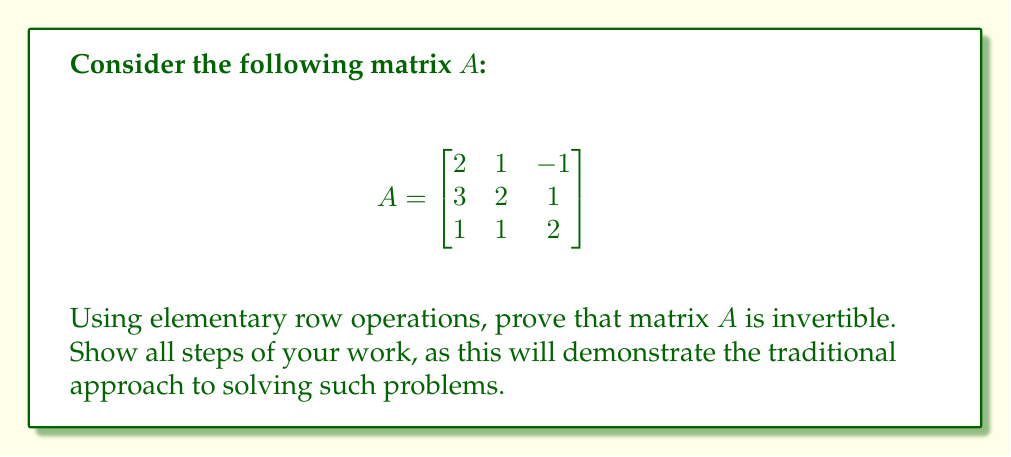Solve this math problem. To prove that matrix $A$ is invertible using elementary row operations, we need to show that we can reduce it to the identity matrix. This process is equivalent to finding the reduced row echelon form (RREF) of the matrix. If we can obtain the identity matrix through elementary row operations, then the matrix is invertible.

Let's proceed step by step:

1) First, we'll augment matrix $A$ with the identity matrix:

   $$\begin{bmatrix}
   2 & 1 & -1 & | & 1 & 0 & 0 \\
   3 & 2 & 1 & | & 0 & 1 & 0 \\
   1 & 1 & 2 & | & 0 & 0 & 1
   \end{bmatrix}$$

2) Now, we'll perform elementary row operations:

   a) Multiply the first row by $-\frac{3}{2}$ and add it to the second row:
   
   $$\begin{bmatrix}
   2 & 1 & -1 & | & 1 & 0 & 0 \\
   0 & \frac{1}{2} & \frac{5}{2} & | & -\frac{3}{2} & 1 & 0 \\
   1 & 1 & 2 & | & 0 & 0 & 1
   \end{bmatrix}$$

   b) Multiply the first row by $-\frac{1}{2}$ and add it to the third row:
   
   $$\begin{bmatrix}
   2 & 1 & -1 & | & 1 & 0 & 0 \\
   0 & \frac{1}{2} & \frac{5}{2} & | & -\frac{3}{2} & 1 & 0 \\
   0 & \frac{1}{2} & \frac{5}{2} & | & -\frac{1}{2} & 0 & 1
   \end{bmatrix}$$

   c) Subtract the second row from the third row:
   
   $$\begin{bmatrix}
   2 & 1 & -1 & | & 1 & 0 & 0 \\
   0 & \frac{1}{2} & \frac{5}{2} & | & -\frac{3}{2} & 1 & 0 \\
   0 & 0 & 0 & | & 1 & -1 & 1
   \end{bmatrix}$$

   d) Multiply the second row by 2:
   
   $$\begin{bmatrix}
   2 & 1 & -1 & | & 1 & 0 & 0 \\
   0 & 1 & 5 & | & -3 & 2 & 0 \\
   0 & 0 & 0 & | & 1 & -1 & 1
   \end{bmatrix}$$

   e) Multiply the third row by -1 and add it to the first row:
   
   $$\begin{bmatrix}
   2 & 1 & -1 & | & 0 & 1 & -1 \\
   0 & 1 & 5 & | & -3 & 2 & 0 \\
   0 & 0 & 0 & | & 1 & -1 & 1
   \end{bmatrix}$$

   f) Multiply the third row by 3 and add it to the second row:
   
   $$\begin{bmatrix}
   2 & 1 & -1 & | & 0 & 1 & -1 \\
   0 & 1 & 5 & | & 0 & -1 & 3 \\
   0 & 0 & 0 & | & 1 & -1 & 1
   \end{bmatrix}$$

   g) Multiply the second row by -1 and add it to the first row:
   
   $$\begin{bmatrix}
   2 & 0 & -6 & | & 0 & 2 & -4 \\
   0 & 1 & 5 & | & 0 & -1 & 3 \\
   0 & 0 & 0 & | & 1 & -1 & 1
   \end{bmatrix}$$

   h) Divide the first row by 2:
   
   $$\begin{bmatrix}
   1 & 0 & -3 & | & 0 & 1 & -2 \\
   0 & 1 & 5 & | & 0 & -1 & 3 \\
   0 & 0 & 0 & | & 1 & -1 & 1
   \end{bmatrix}$$

3) We have now reduced the left side of the augmented matrix to row echelon form. Since there is a pivot in each column, the matrix is invertible.

4) The right side of the augmented matrix gives us the inverse of $A$:

   $$A^{-1} = \begin{bmatrix}
   0 & 1 & -2 \\
   0 & -1 & 3 \\
   1 & -1 & 1
   \end{bmatrix}$$
Answer: Matrix $A$ is invertible. Its inverse is:

$$A^{-1} = \begin{bmatrix}
0 & 1 & -2 \\
0 & -1 & 3 \\
1 & -1 & 1
\end{bmatrix}$$ 